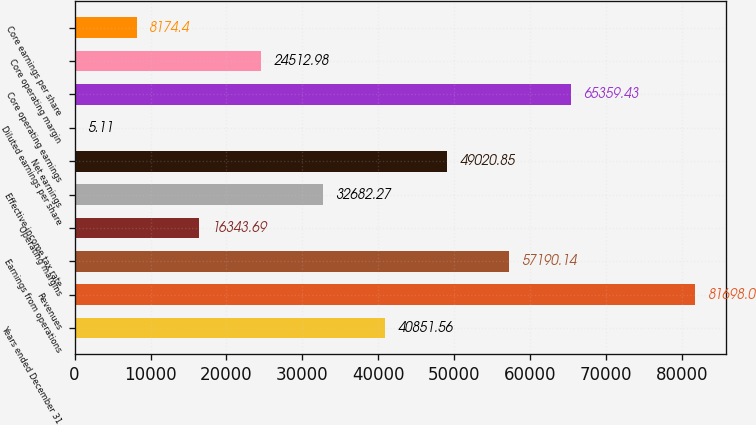Convert chart. <chart><loc_0><loc_0><loc_500><loc_500><bar_chart><fcel>Years ended December 31<fcel>Revenues<fcel>Earnings from operations<fcel>Operating margins<fcel>Effective income tax rate<fcel>Net earnings<fcel>Diluted earnings per share<fcel>Core operating earnings<fcel>Core operating margin<fcel>Core earnings per share<nl><fcel>40851.6<fcel>81698<fcel>57190.1<fcel>16343.7<fcel>32682.3<fcel>49020.8<fcel>5.11<fcel>65359.4<fcel>24513<fcel>8174.4<nl></chart> 